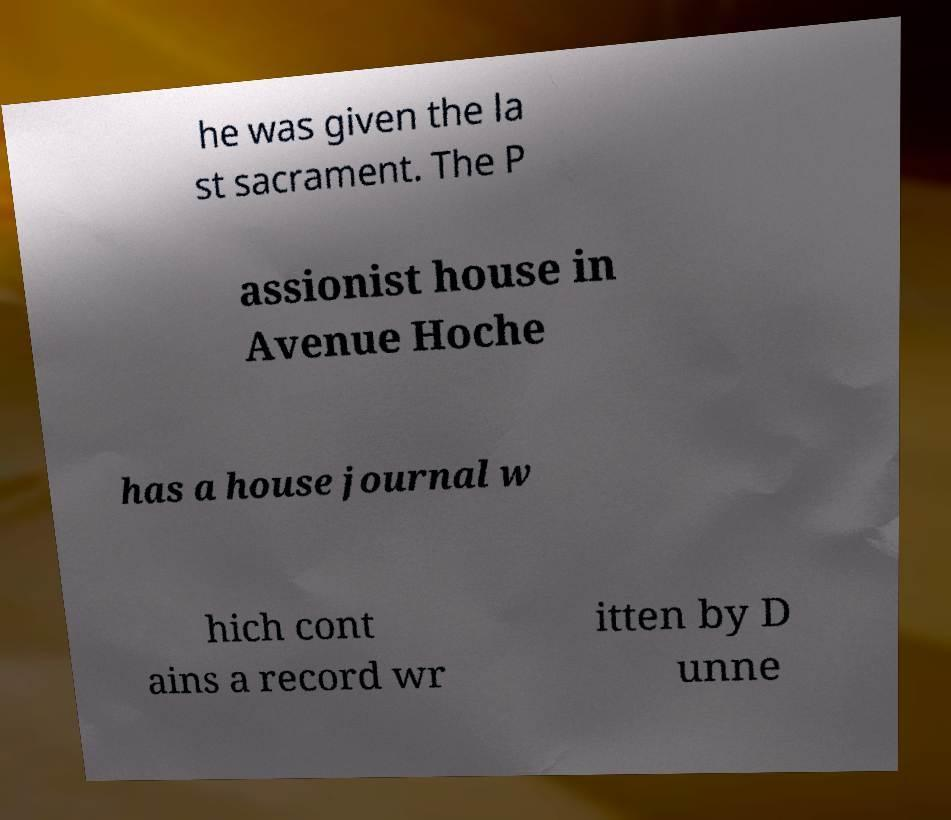Can you accurately transcribe the text from the provided image for me? he was given the la st sacrament. The P assionist house in Avenue Hoche has a house journal w hich cont ains a record wr itten by D unne 